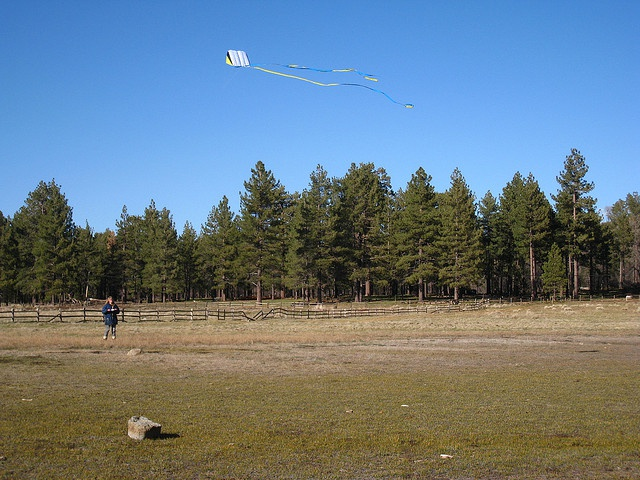Describe the objects in this image and their specific colors. I can see kite in gray, lightblue, and lavender tones and people in gray, black, navy, and darkgray tones in this image. 